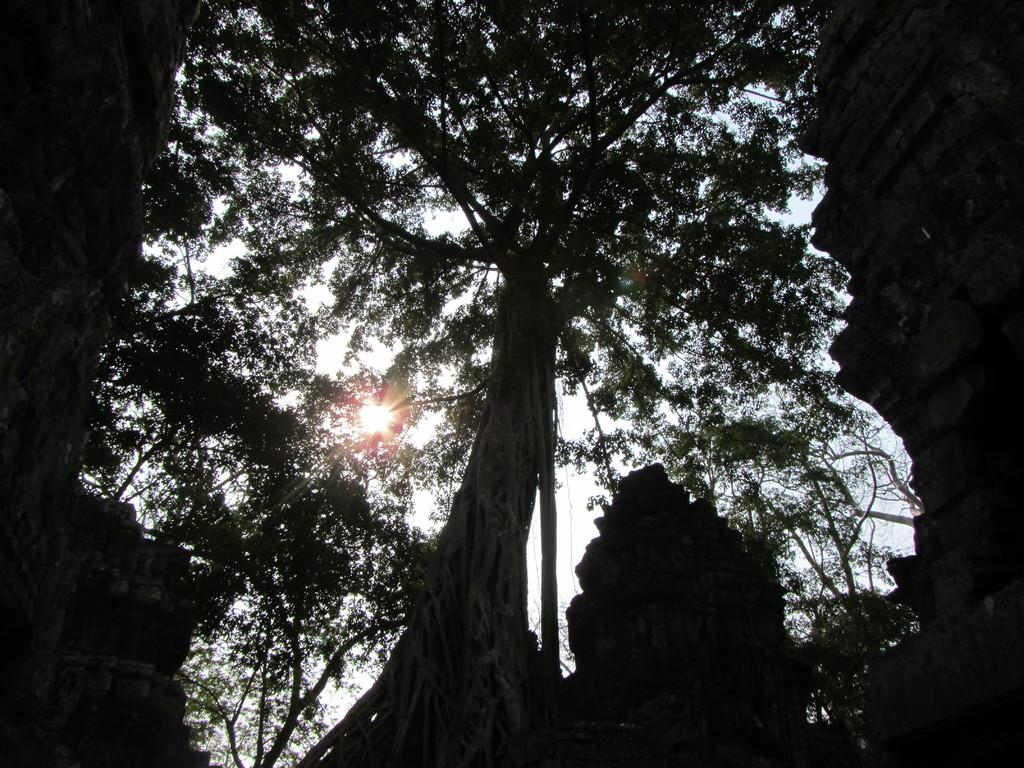What type of structures can be seen in the image? There are monuments in the image. What natural elements are present in the image? There are many trees in the image. What celestial body is visible in the image? There is a sun visible in the image. What part of the natural environment is visible in the image? There is a sky visible in the image. Can you see a horse in the image? There is no horse present in the image. 